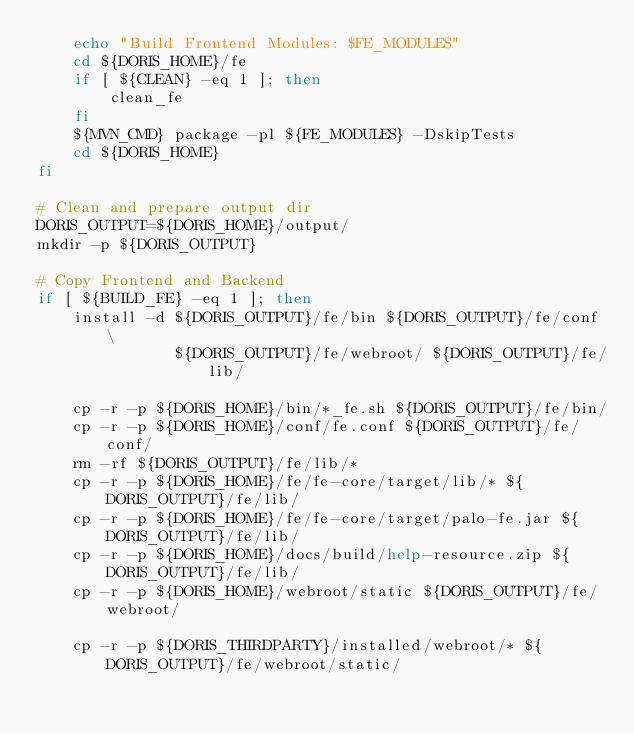<code> <loc_0><loc_0><loc_500><loc_500><_Bash_>    echo "Build Frontend Modules: $FE_MODULES"
    cd ${DORIS_HOME}/fe
    if [ ${CLEAN} -eq 1 ]; then
        clean_fe
    fi
    ${MVN_CMD} package -pl ${FE_MODULES} -DskipTests
    cd ${DORIS_HOME}
fi

# Clean and prepare output dir
DORIS_OUTPUT=${DORIS_HOME}/output/
mkdir -p ${DORIS_OUTPUT}

# Copy Frontend and Backend
if [ ${BUILD_FE} -eq 1 ]; then
    install -d ${DORIS_OUTPUT}/fe/bin ${DORIS_OUTPUT}/fe/conf \
               ${DORIS_OUTPUT}/fe/webroot/ ${DORIS_OUTPUT}/fe/lib/

    cp -r -p ${DORIS_HOME}/bin/*_fe.sh ${DORIS_OUTPUT}/fe/bin/
    cp -r -p ${DORIS_HOME}/conf/fe.conf ${DORIS_OUTPUT}/fe/conf/
    rm -rf ${DORIS_OUTPUT}/fe/lib/*
    cp -r -p ${DORIS_HOME}/fe/fe-core/target/lib/* ${DORIS_OUTPUT}/fe/lib/
    cp -r -p ${DORIS_HOME}/fe/fe-core/target/palo-fe.jar ${DORIS_OUTPUT}/fe/lib/
    cp -r -p ${DORIS_HOME}/docs/build/help-resource.zip ${DORIS_OUTPUT}/fe/lib/
    cp -r -p ${DORIS_HOME}/webroot/static ${DORIS_OUTPUT}/fe/webroot/

    cp -r -p ${DORIS_THIRDPARTY}/installed/webroot/* ${DORIS_OUTPUT}/fe/webroot/static/</code> 